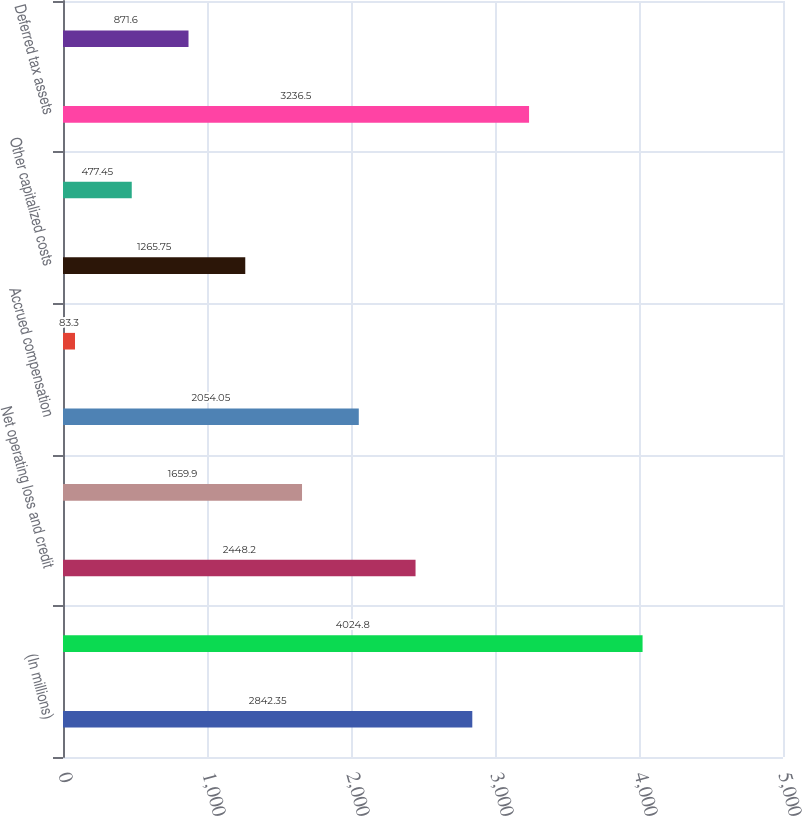Convert chart to OTSL. <chart><loc_0><loc_0><loc_500><loc_500><bar_chart><fcel>(In millions)<fcel>Depreciation and amortization<fcel>Net operating loss and credit<fcel>Reserves and accruals<fcel>Accrued compensation<fcel>Inventory basis difference<fcel>Other capitalized costs<fcel>Other net<fcel>Deferred tax assets<fcel>Less Valuation allowance<nl><fcel>2842.35<fcel>4024.8<fcel>2448.2<fcel>1659.9<fcel>2054.05<fcel>83.3<fcel>1265.75<fcel>477.45<fcel>3236.5<fcel>871.6<nl></chart> 